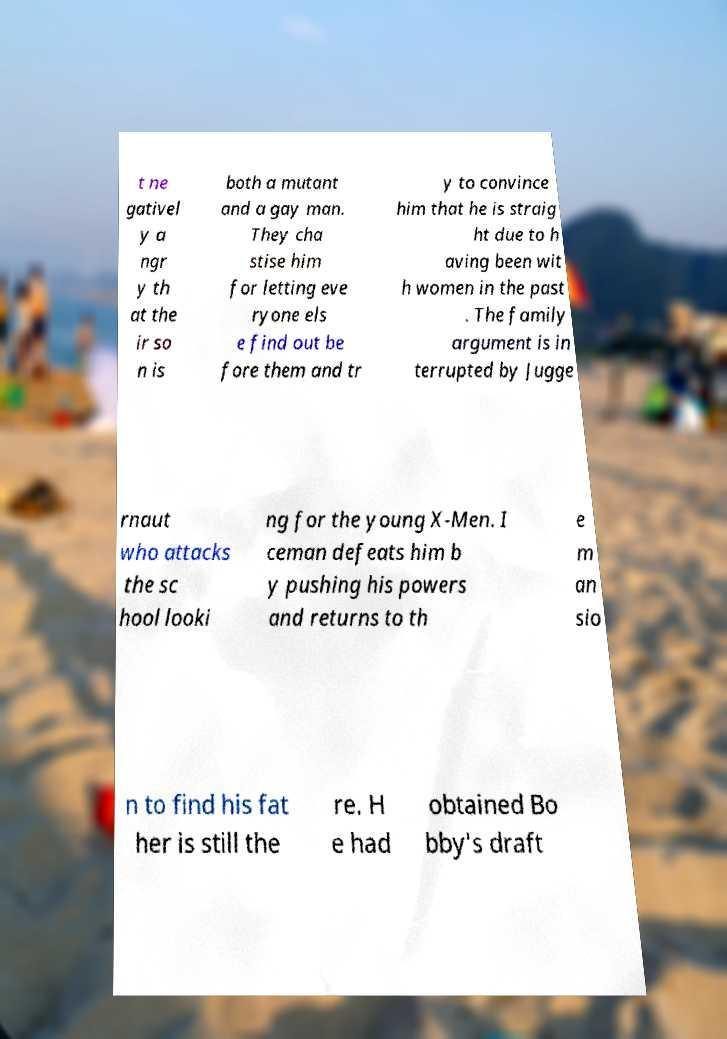What messages or text are displayed in this image? I need them in a readable, typed format. t ne gativel y a ngr y th at the ir so n is both a mutant and a gay man. They cha stise him for letting eve ryone els e find out be fore them and tr y to convince him that he is straig ht due to h aving been wit h women in the past . The family argument is in terrupted by Jugge rnaut who attacks the sc hool looki ng for the young X-Men. I ceman defeats him b y pushing his powers and returns to th e m an sio n to find his fat her is still the re. H e had obtained Bo bby's draft 